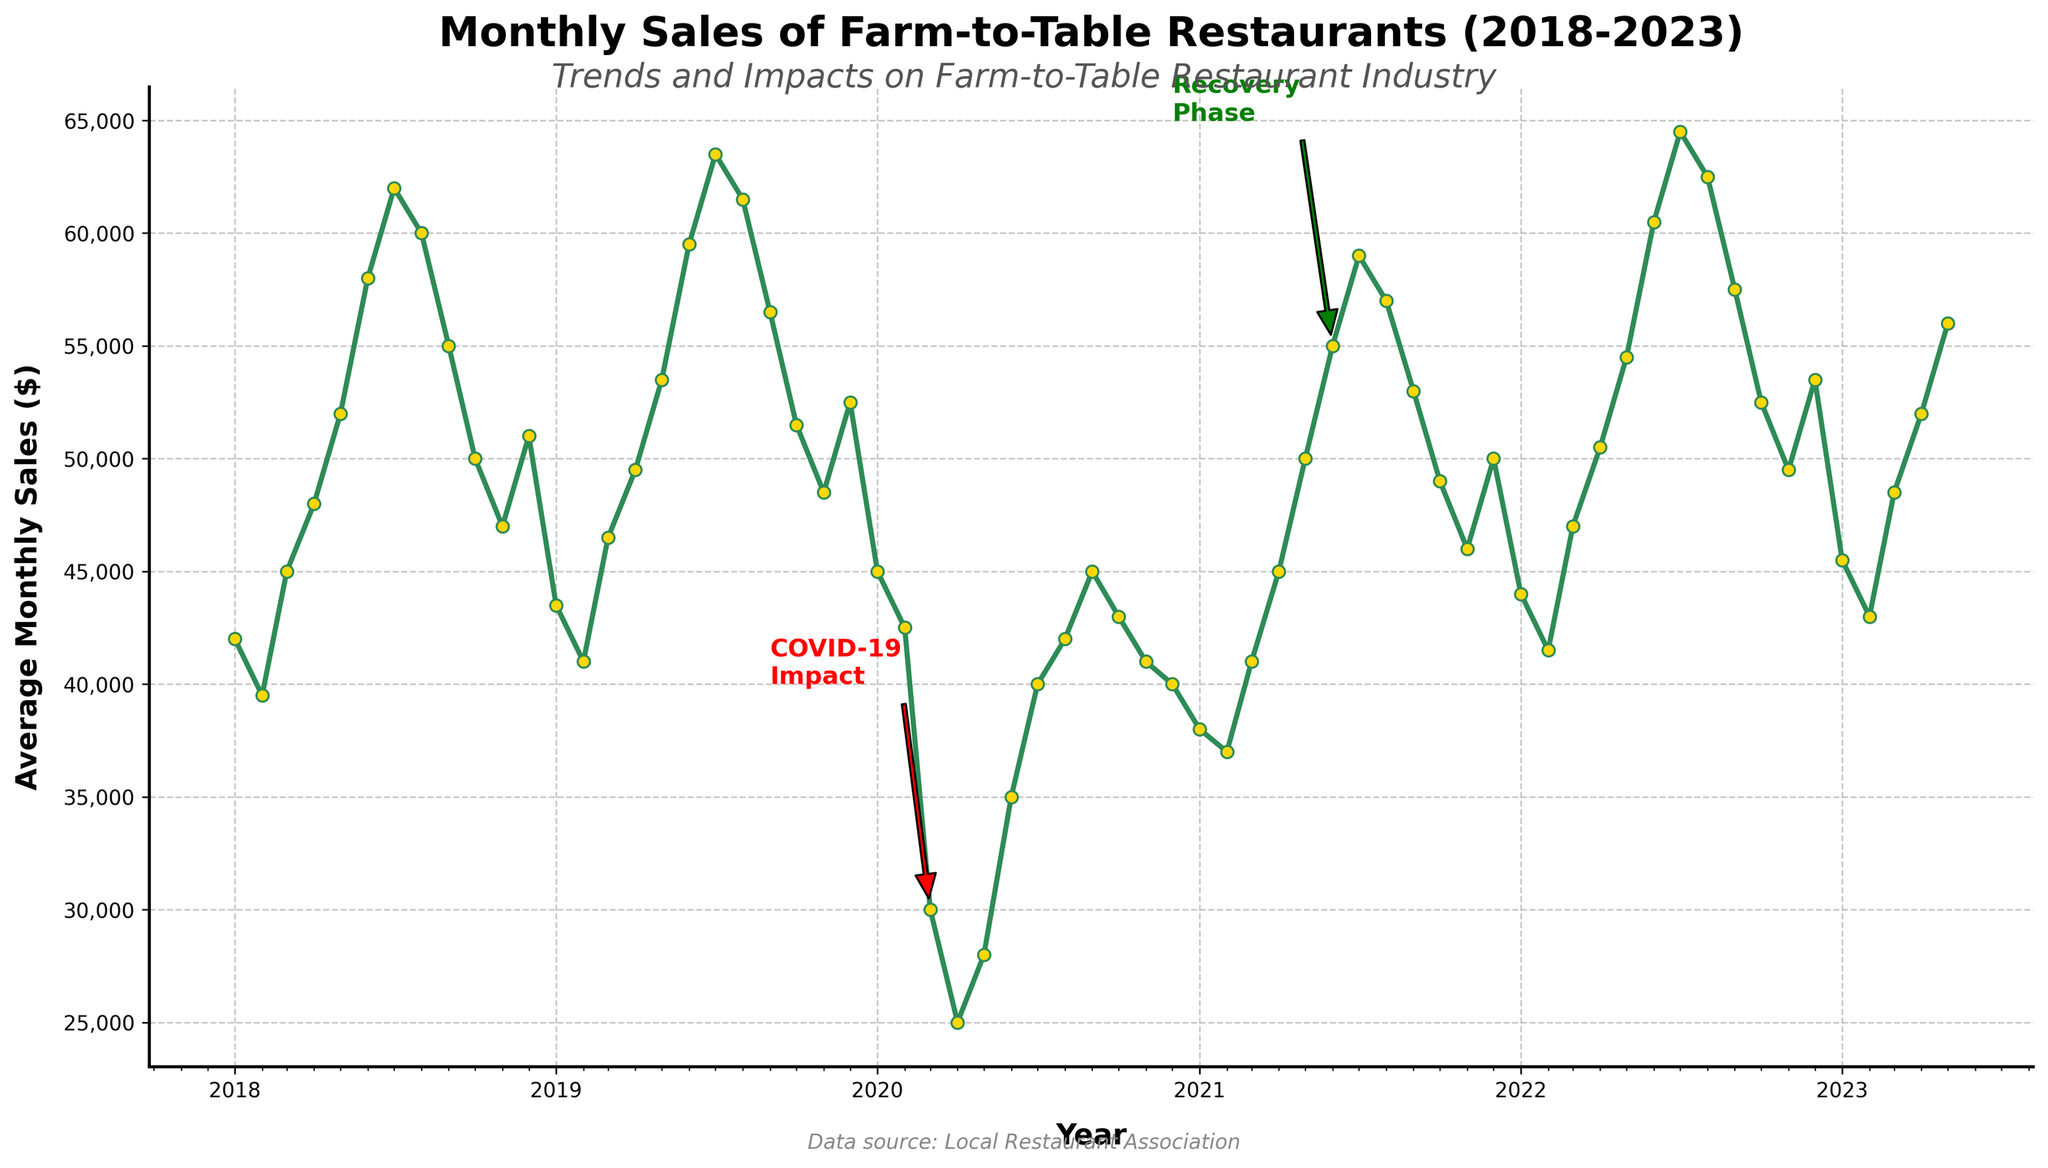what is the average monthly sale in 2021? To find the average monthly sale in 2021, sum the monthly sales for 2021 and divide by the number of months. The monthly sales are: 38000, 37000, 41000, 45000, 50000, 55000, 59000, 57000, 53000, 49000, 46000, and 50000. Sum = 610000. Average = 610000 / 12 = 50833.33
Answer: 50833.33 what is the difference in average monthly sales between Dec 2019 and Dec 2020? To find the difference, subtract the average monthly sales in Dec 2019 (52500) from Dec 2020 (40000). Difference = 52500 - 40000 = 12500
Answer: 12500 which month had the highest average monthly sales in 2022? To find the month with the highest average monthly sales in 2022, look at the data for 2022: 44000, 41500, 47000, 50500, 54500, 60500, 64500, 62500, 57500, 52500, 49500, and 53500. July had the highest value (64500)
Answer: July During which period did the average monthly sales decrease due to COVID-19 impact? The annotation 'COVID-19 Impact' highlights a drop starting from March 2020. From the data, sales fell significantly from Mar 2020 (30000), Apr 2020 (25000), and May 2020 (28000), compared to previous months.
Answer: March to May 2020 how does average monthly sales in the recovery phase compare to the previous periods? Compare the annotated recovery phase (starting from Jun 2021 with 55000) to previous months; June 2020 to May 2021 sales (ranging from 35000 to 50000). The recovery phase shows a marked increase in monthly sales.
Answer: Higher what was the average monthly sales growth from Jan 2018 to Jul 2018? To find the growth from Jan to Jul 2018, subtract Jan 2018's sales (42000) from Jul 2018's (62000): 62000 - 42000 = 20000.
Answer: 20000 from which month in 2021 did the average monthly sales start to recover significantly? By inspecting the sales in 2021, the sales significantly increased from May 2021 (50000) compared to previous months (37000-45000).
Answer: May 2021 how does the average sales in 2023 compare to 2020? By comparing the available data points, Jan 2023 (45500) is higher than Jan 2020 (45000); Apr 2023 (52000) is higher than Apr 2020 (25000). The sales in 2023 show a significant increase compared to 2020.
Answer: Higher 